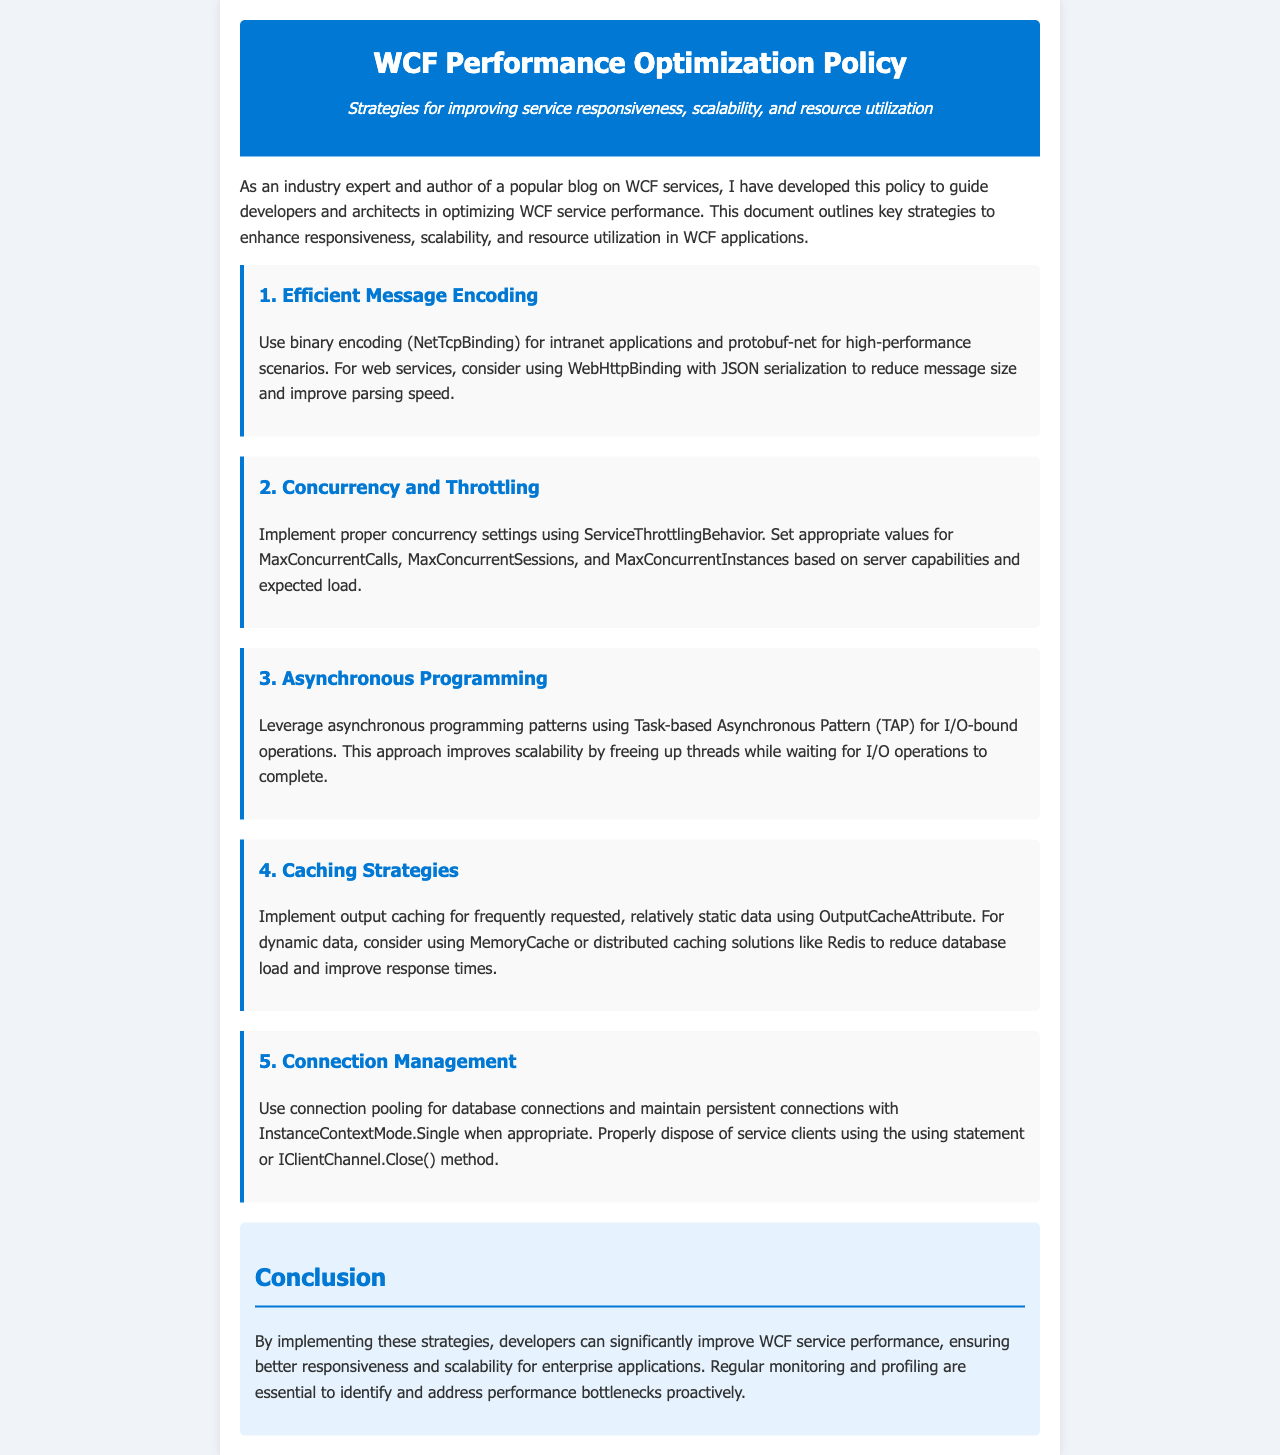what is the title of the document? The title is explicitly stated in the header of the document as "WCF Performance Optimization Policy."
Answer: WCF Performance Optimization Policy what is a recommended encoding for intranet applications? The document mentions using binary encoding (NetTcpBinding) for intranet applications.
Answer: binary encoding (NetTcpBinding) what behavior should be implemented for concurrency settings? The document suggests implementing proper concurrency settings using ServiceThrottlingBehavior.
Answer: ServiceThrottlingBehavior what pattern is recommended for asynchronous programming? The document recommends using Task-based Asynchronous Pattern (TAP) for asynchronous programming.
Answer: Task-based Asynchronous Pattern (TAP) which caching solution can help reduce database load? The document mentions using MemoryCache or distributed caching solutions like Redis for reducing database load.
Answer: MemoryCache or Redis how many specific strategies are outlined in the document? The document lists a total of five strategies for optimizing WCF performance.
Answer: five what is the main purpose of the document? The main purpose is to guide developers and architects in optimizing WCF service performance.
Answer: guide developers and architects what should developers do to dispose of service clients? The document explains that developers should use the using statement or IClientChannel.Close() method to dispose of service clients.
Answer: using statement or IClientChannel.Close() method what is mentioned as essential for identifying performance bottlenecks? The document states that regular monitoring and profiling are essential to address performance bottlenecks.
Answer: regular monitoring and profiling 